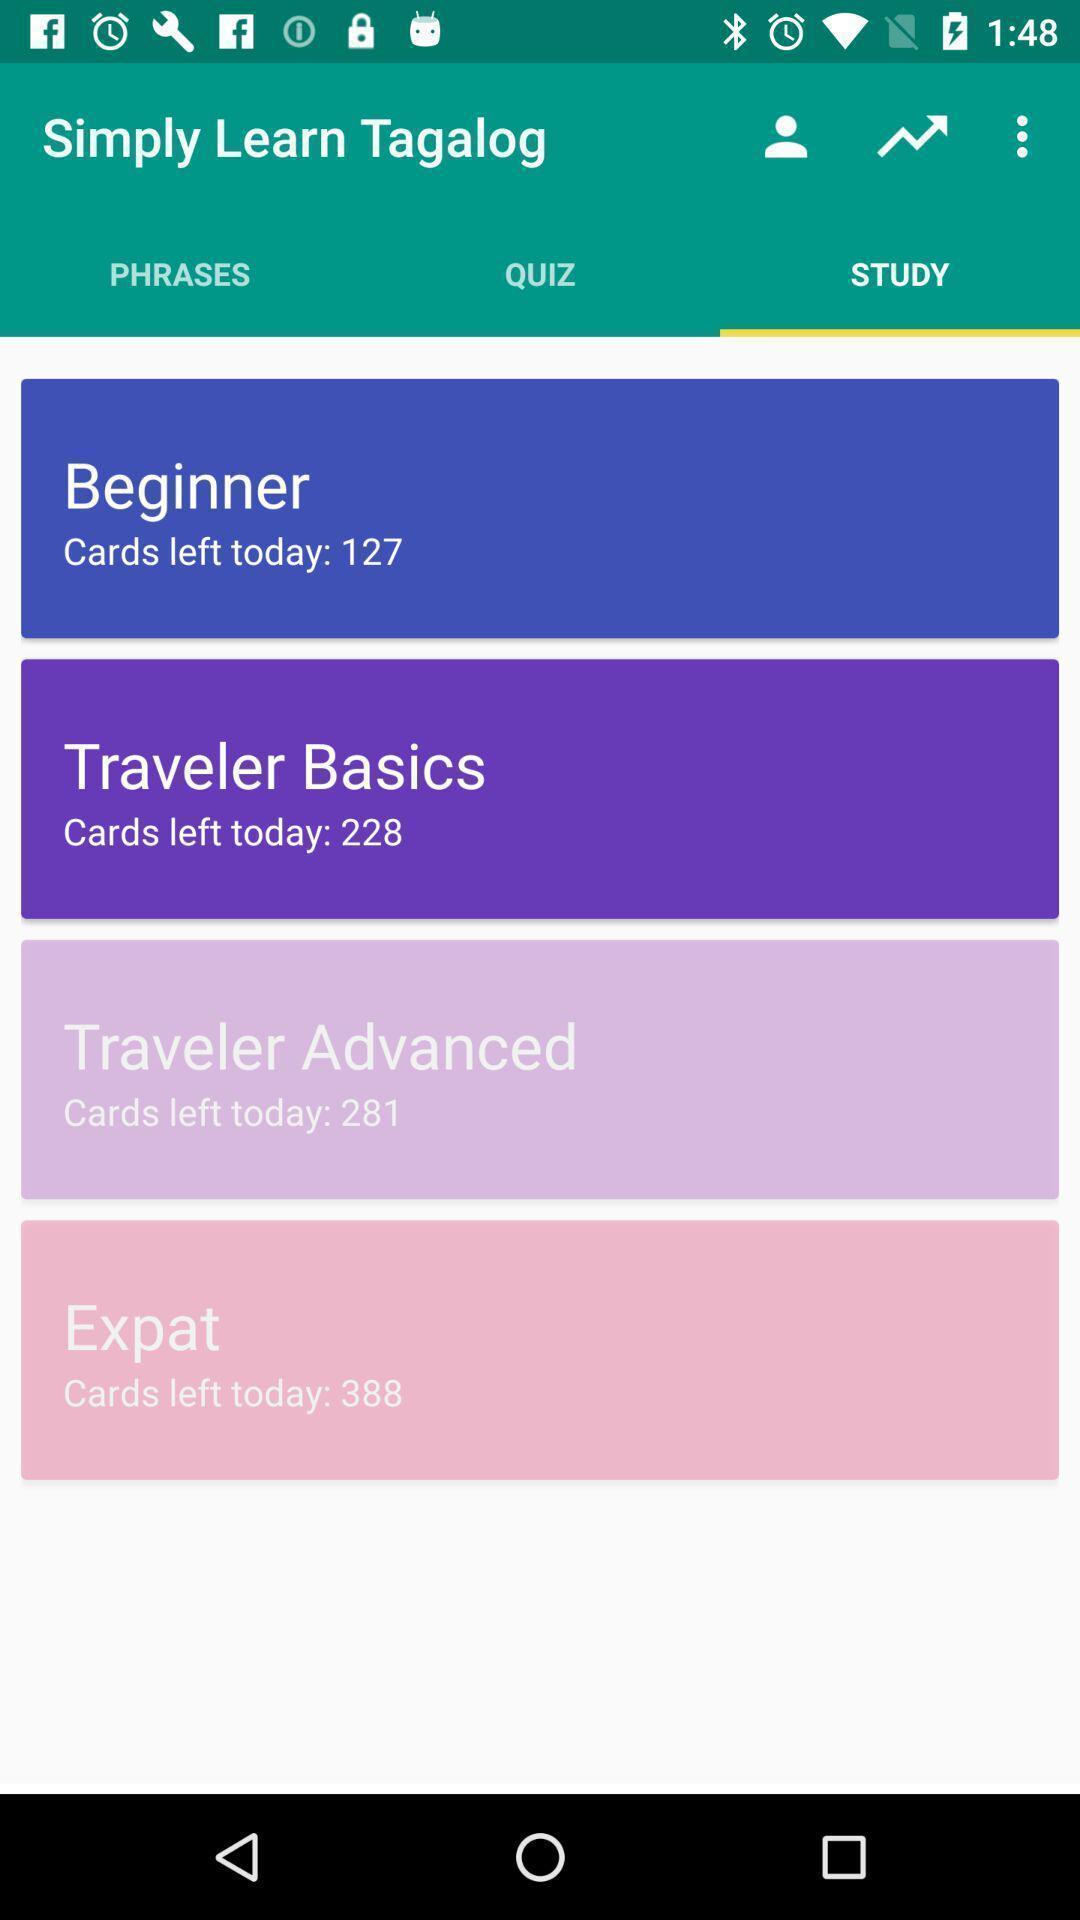Summarize the information in this screenshot. Screen shows multiple options in a learning application. 